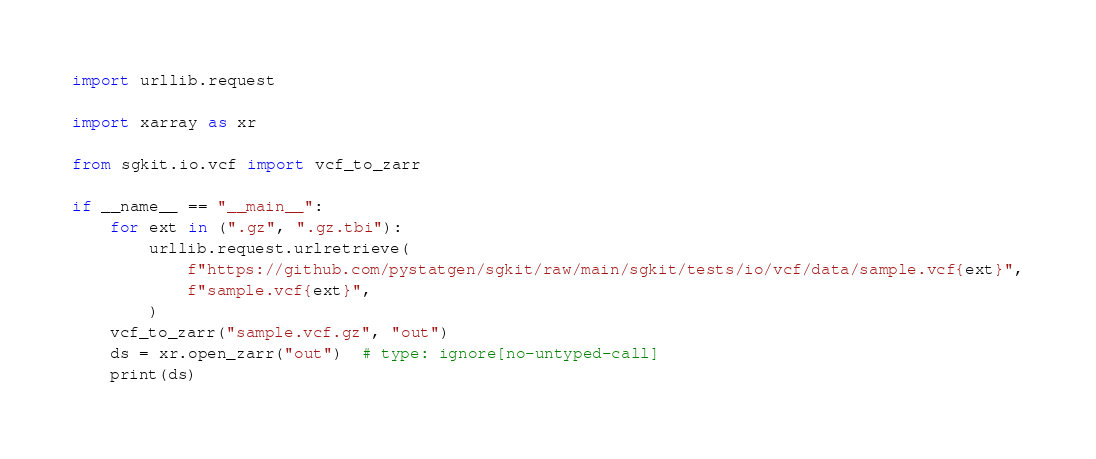Convert code to text. <code><loc_0><loc_0><loc_500><loc_500><_Python_>import urllib.request

import xarray as xr

from sgkit.io.vcf import vcf_to_zarr

if __name__ == "__main__":
    for ext in (".gz", ".gz.tbi"):
        urllib.request.urlretrieve(
            f"https://github.com/pystatgen/sgkit/raw/main/sgkit/tests/io/vcf/data/sample.vcf{ext}",
            f"sample.vcf{ext}",
        )
    vcf_to_zarr("sample.vcf.gz", "out")
    ds = xr.open_zarr("out")  # type: ignore[no-untyped-call]
    print(ds)
</code> 